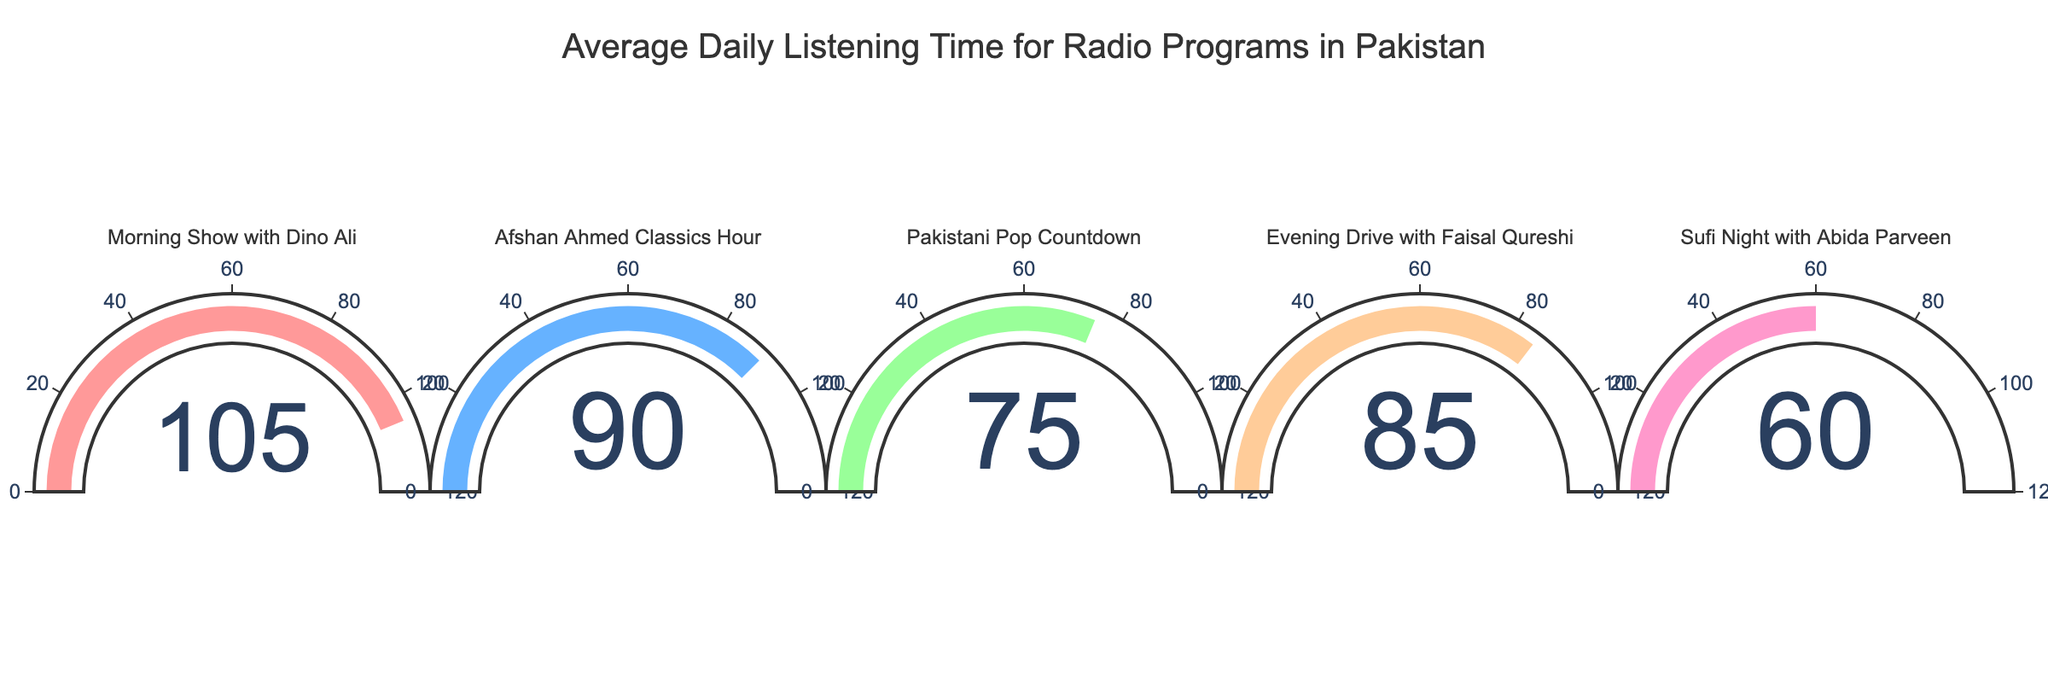What is the title of the chart? The title is displayed prominently at the top of the chart.
Answer: Average Daily Listening Time for Radio Programs in Pakistan How many radio programs are shown in the chart? By counting the number of gauge indicators in the chart, it's clear there are five programs.
Answer: 5 Which radio program has the highest average daily listening time? The gauge indicating "Morning Show with Dino Ali" has its needle pointing to the highest value.
Answer: Morning Show with Dino Ali What's the average daily listening time for "Afshan Ahmed Classics Hour"? The gauge for "Afshan Ahmed Classics Hour" shows the needle pointing at 90.
Answer: 90 minutes What's the difference in average daily listening time between "Evening Drive with Faisal Qureshi" and "Sufi Night with Abida Parveen"? "Evening Drive with Faisal Qureshi" has a value of 85, and "Sufi Night with Abida Parveen" has a value of 60. The difference is 85 - 60.
Answer: 25 minutes Arrange the radio programs in ascending order of average daily listening time. The values on the gauges from smallest to largest are: "Sufi Night with Abida Parveen" (60), "Pakistani Pop Countdown" (75), "Evening Drive with Faisal Qureshi" (85), "Afshan Ahmed Classics Hour" (90), "Morning Show with Dino Ali" (105).
Answer: Sufi Night with Abida Parveen, Pakistani Pop Countdown, Evening Drive with Faisal Qureshi, Afshan Ahmed Classics Hour, Morning Show with Dino Ali By how many minutes does "Morning Show with Dino Ali" exceed the halfway point of the gauge's maximum value? Halfway on the gauge's maximum of 120 minutes is 60. "Morning Show with Dino Ali" is at 105. The difference is 105 - 60.
Answer: 45 minutes What's the combined average daily listening time for the three programs with the lowest values? The three lowest values are for "Pakistani Pop Countdown" (75), "Evening Drive with Faisal Qureshi" (85), and "Sufi Night with Abida Parveen" (60). Summing these up: 75 + 85 + 60.
Answer: 220 minutes Which radio programs' average daily listening time falls within the range 70 to 95 minutes? From the gauges: "Pakistani Pop Countdown" (75), "Evening Drive with Faisal Qureshi" (85), and "Afshan Ahmed Classics Hour" (90) fall within 70 to 95 minutes.
Answer: Pakistani Pop Countdown, Evening Drive with Faisal Qureshi, Afshan Ahmed Classics Hour 